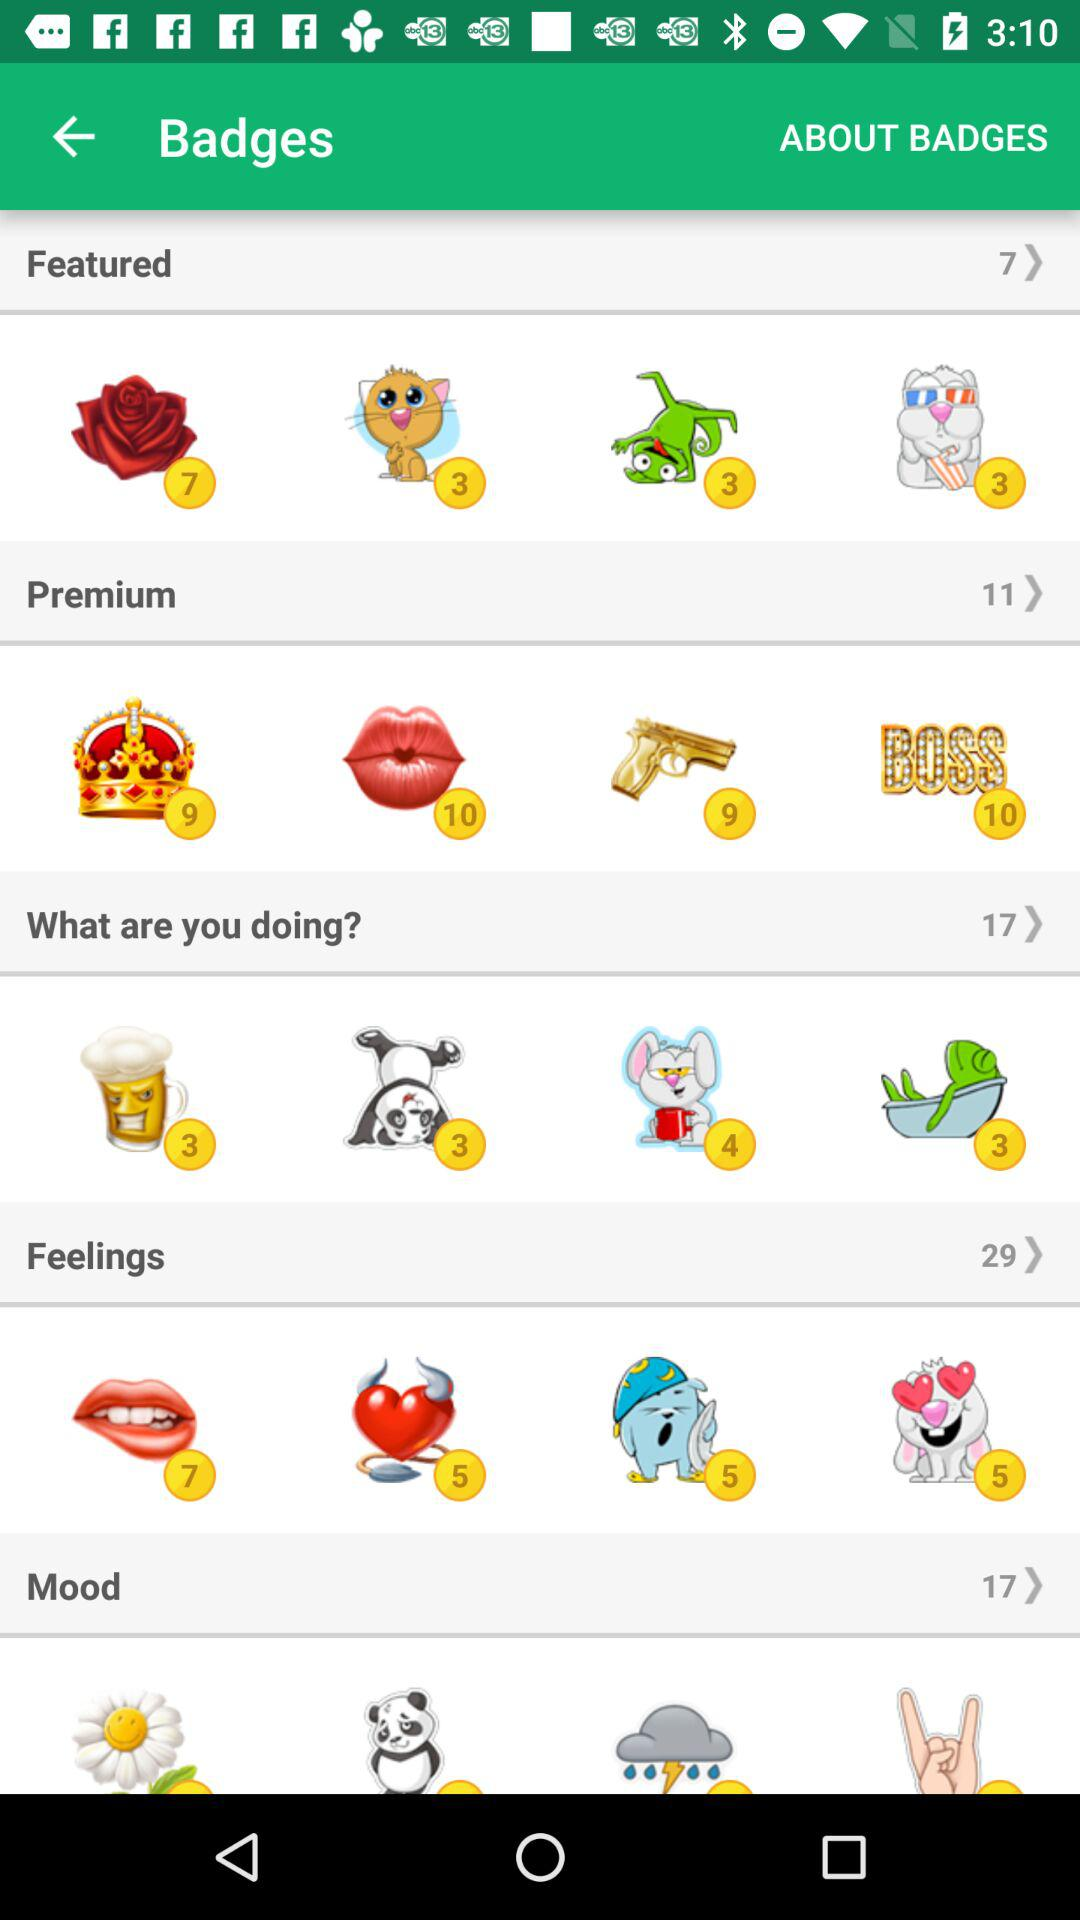What is the total number of premium badges? The total number of premium badges is 11. 